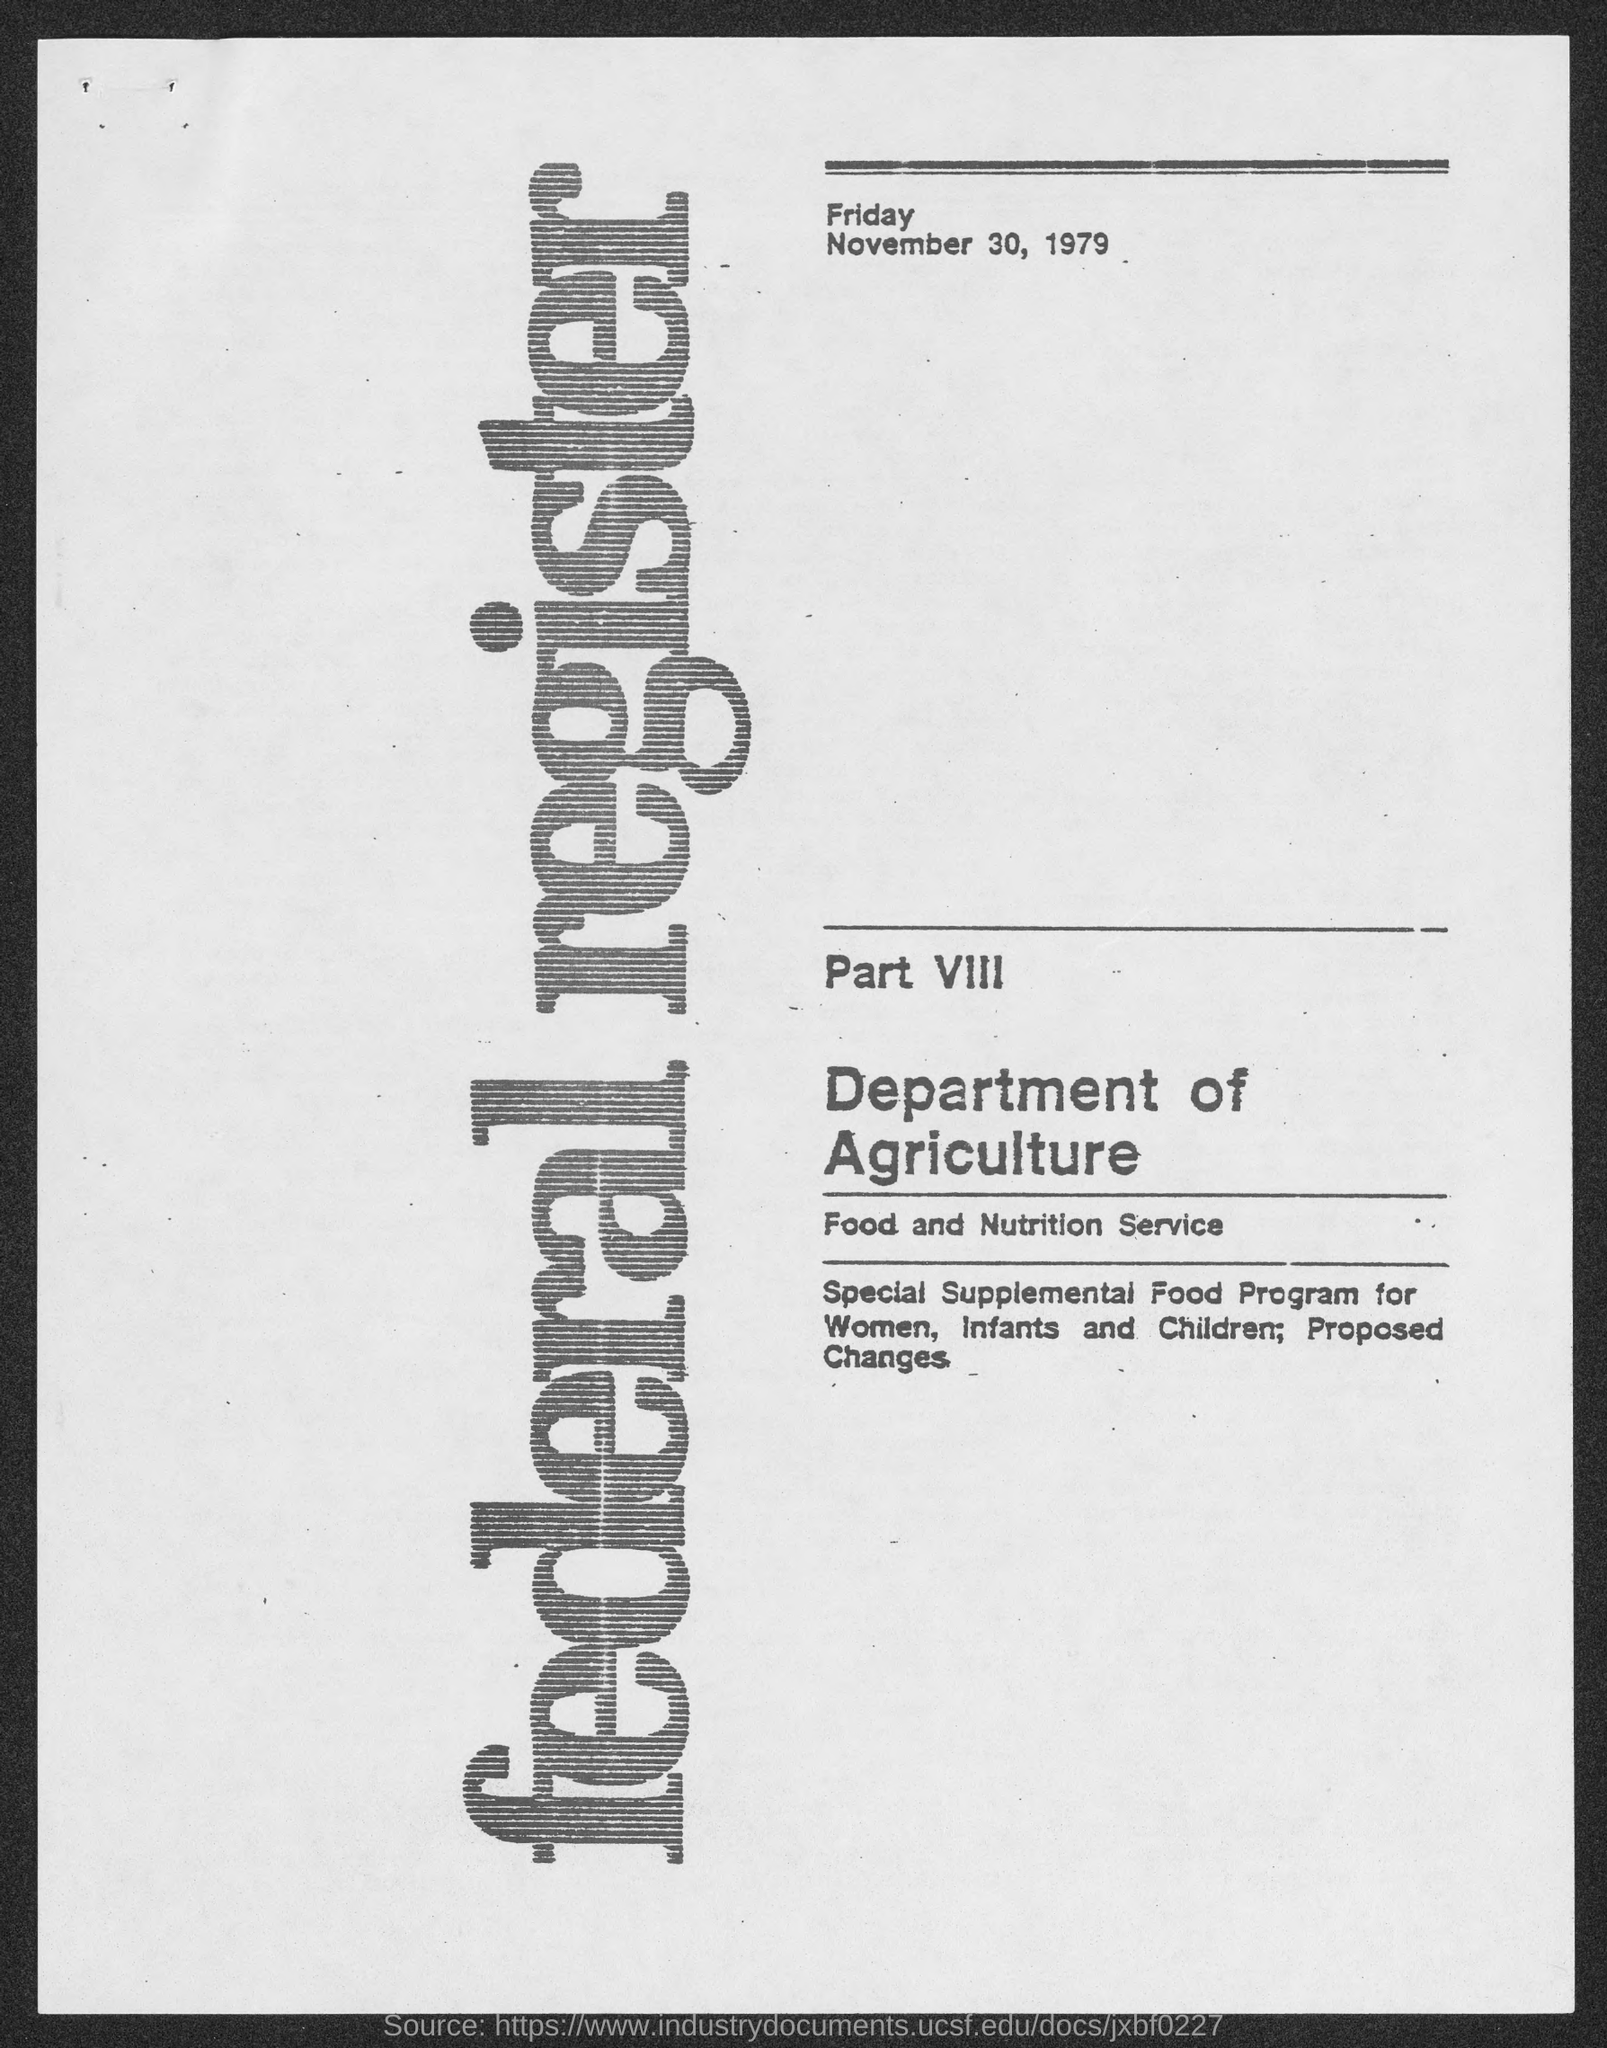Which is the Department mentioned in the document?
Give a very brief answer. Department of agriculture. Which is the day mentioned at the top of the document?
Provide a succinct answer. Friday. What is the date mentioned below 'Friday'?
Offer a very short reply. November 30, 1979. 